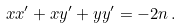Convert formula to latex. <formula><loc_0><loc_0><loc_500><loc_500>x x ^ { \prime } + x y ^ { \prime } + y y ^ { \prime } = - 2 n \, .</formula> 